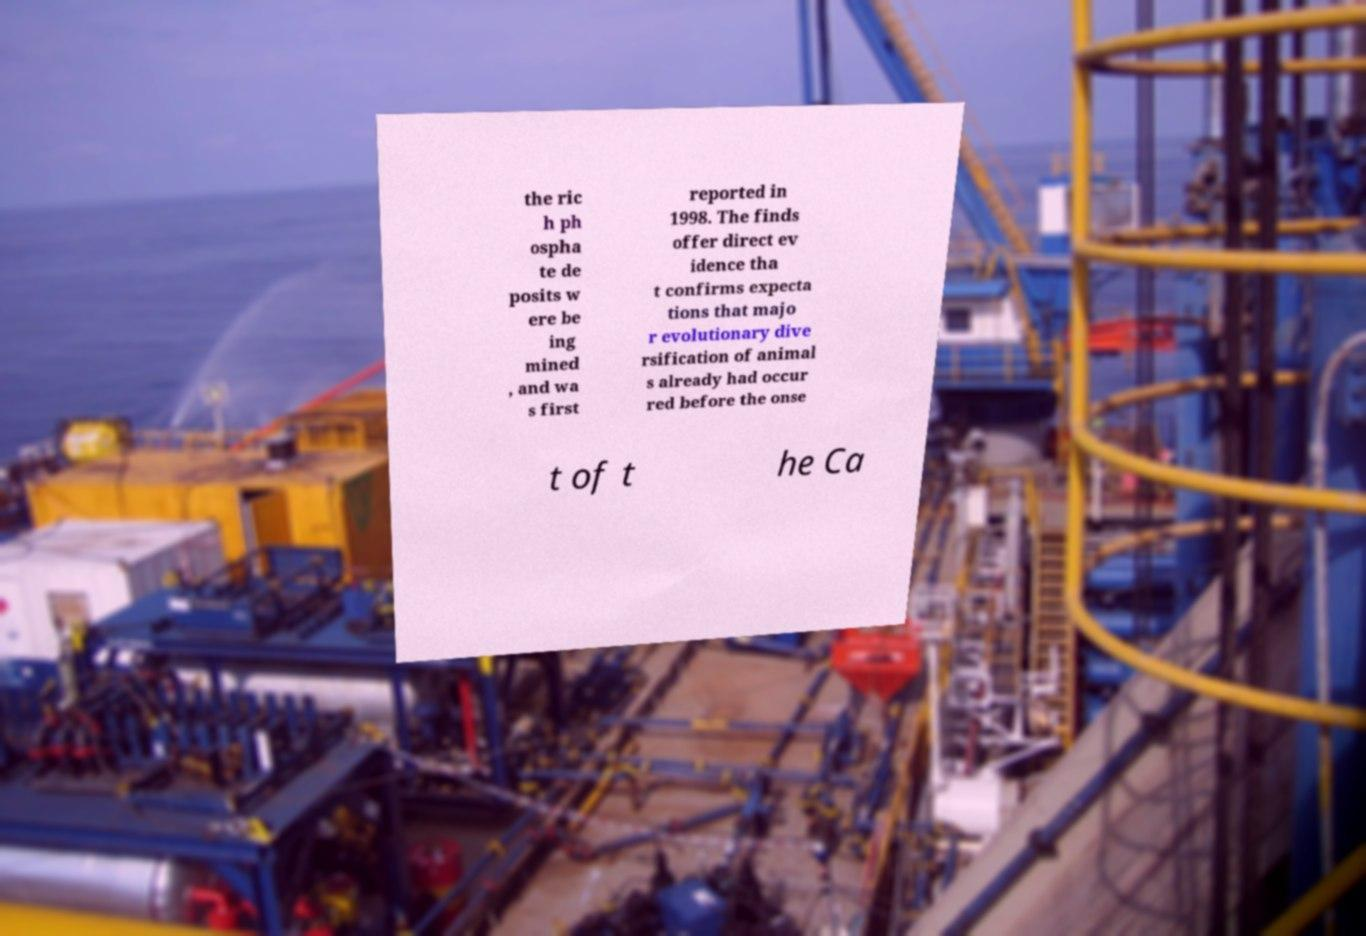Please read and relay the text visible in this image. What does it say? the ric h ph ospha te de posits w ere be ing mined , and wa s first reported in 1998. The finds offer direct ev idence tha t confirms expecta tions that majo r evolutionary dive rsification of animal s already had occur red before the onse t of t he Ca 